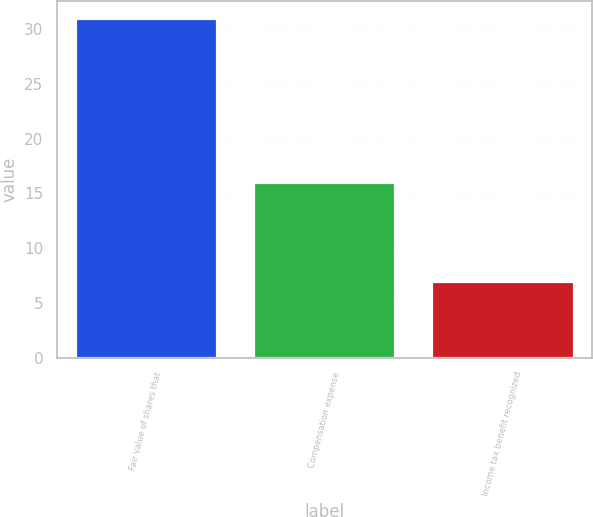Convert chart. <chart><loc_0><loc_0><loc_500><loc_500><bar_chart><fcel>Fair value of shares that<fcel>Compensation expense<fcel>Income tax benefit recognized<nl><fcel>31<fcel>16<fcel>7<nl></chart> 